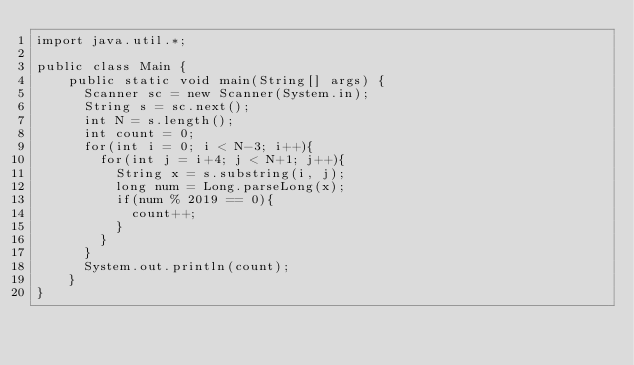Convert code to text. <code><loc_0><loc_0><loc_500><loc_500><_Java_>import java.util.*;

public class Main { 
    public static void main(String[] args) {
      Scanner sc = new Scanner(System.in);
      String s = sc.next();
      int N = s.length();
      int count = 0;
      for(int i = 0; i < N-3; i++){
        for(int j = i+4; j < N+1; j++){
          String x = s.substring(i, j);
          long num = Long.parseLong(x);
          if(num % 2019 == 0){
            count++;
          }
        }
      }
      System.out.println(count);
    }
}
</code> 